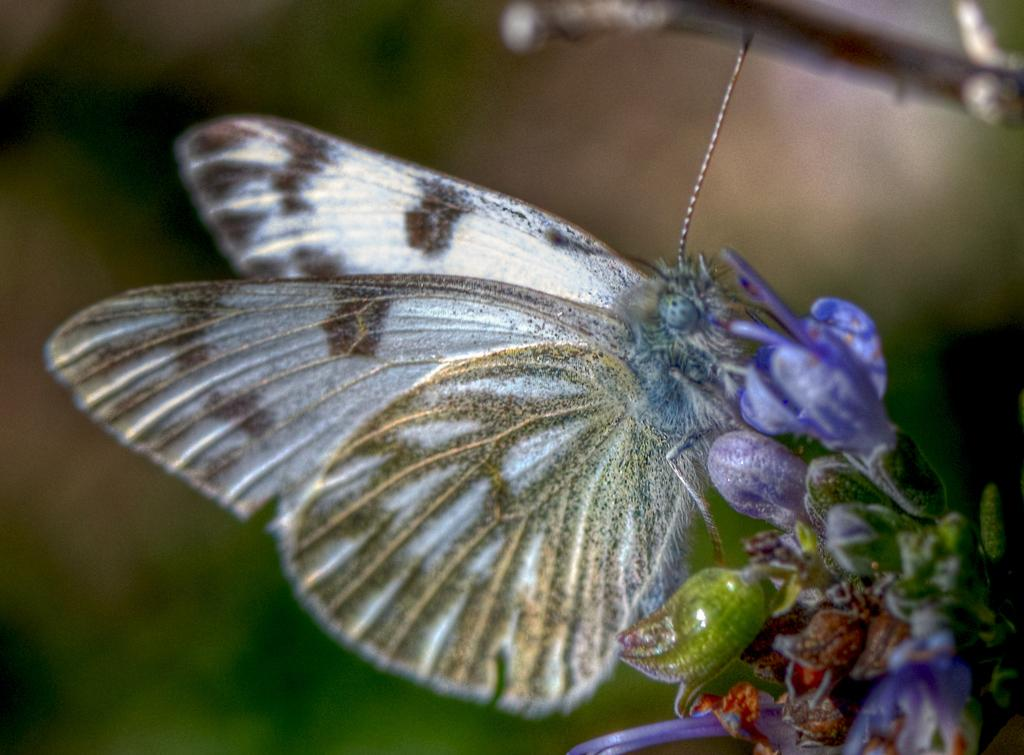What type of creature can be seen in the picture? There is a flying insect in the picture. Where is the insect located in the picture? The insect is on a flower in the picture. What else can be seen in the picture besides the insect? There are flowers in the picture. Can you describe the flowers on the right side of the picture? There are flower buds on the right side of the picture. What type of yarn is being used to create the reward for the drawer in the picture? There is no yarn, drawer, or reward present in the picture. 